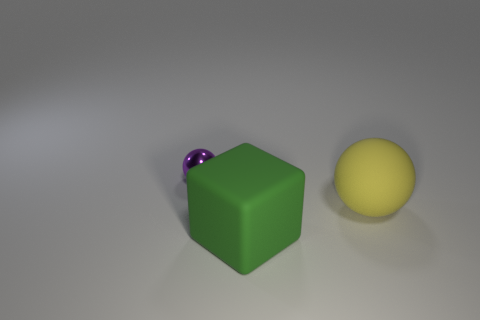Add 2 green objects. How many objects exist? 5 Subtract all blocks. How many objects are left? 2 Subtract 0 purple cylinders. How many objects are left? 3 Subtract all purple metallic spheres. Subtract all purple metallic things. How many objects are left? 1 Add 1 matte balls. How many matte balls are left? 2 Add 1 big green cylinders. How many big green cylinders exist? 1 